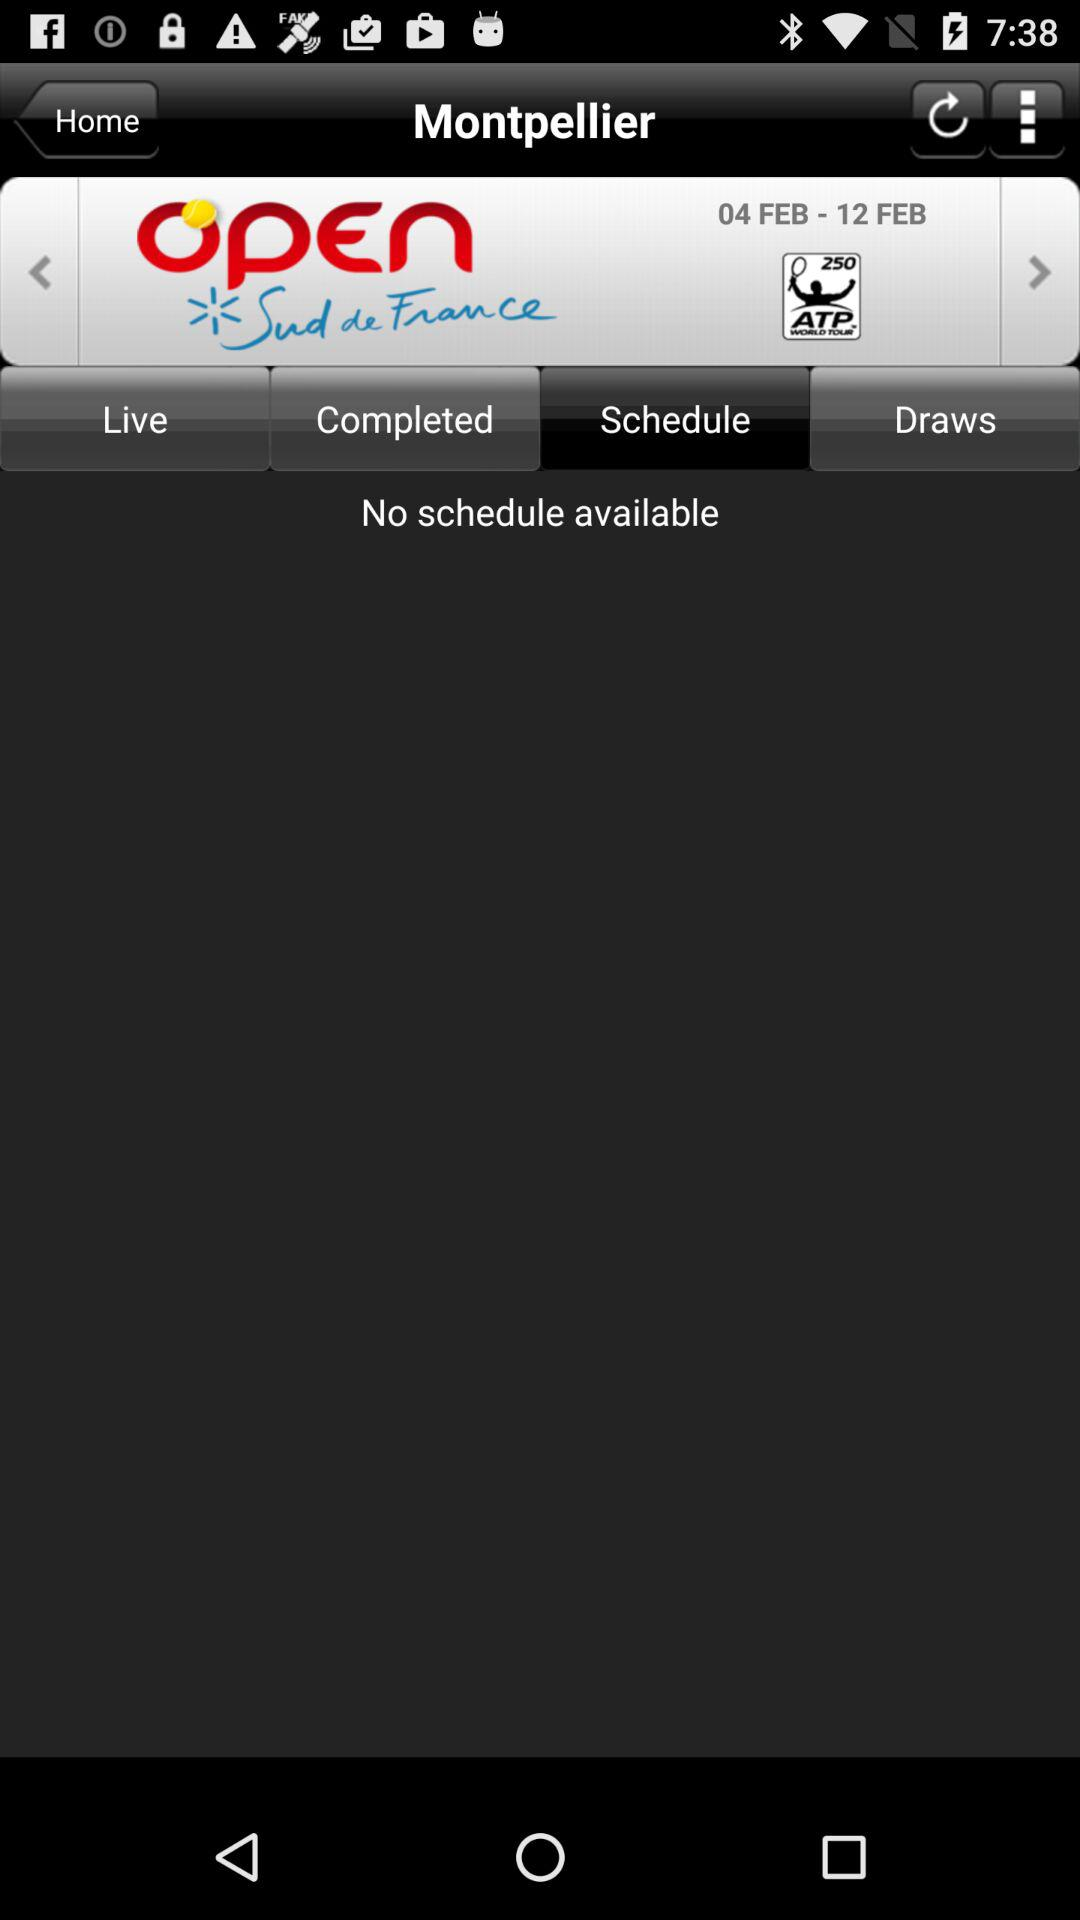Which tab is selected? The selected tab is "Schedule". 